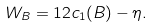Convert formula to latex. <formula><loc_0><loc_0><loc_500><loc_500>W _ { B } = 1 2 c _ { 1 } ( B ) - \eta .</formula> 